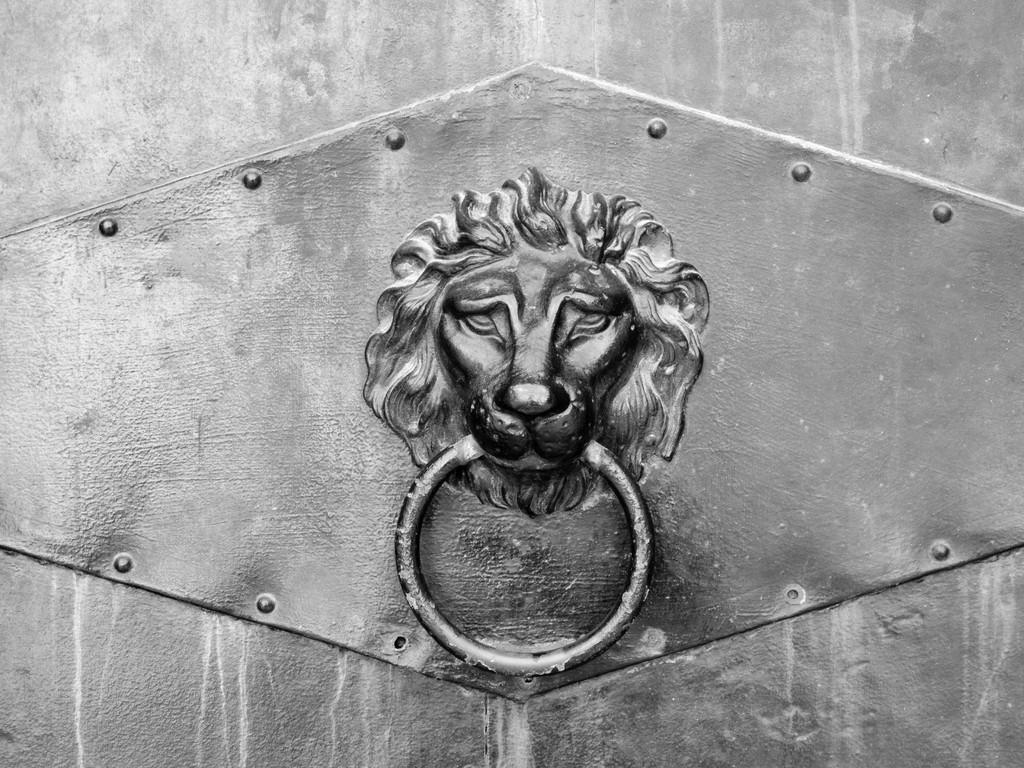What is the color scheme of the image? The image is black and white. What can be seen in the image? There is a door in the image. What is unique about the door knocker in the image? The door knocker is in the shape of a lion. What scientific concept is being taught in the image? There is no scientific concept or teaching present in the image; it features a door with a lion-shaped door knocker. 